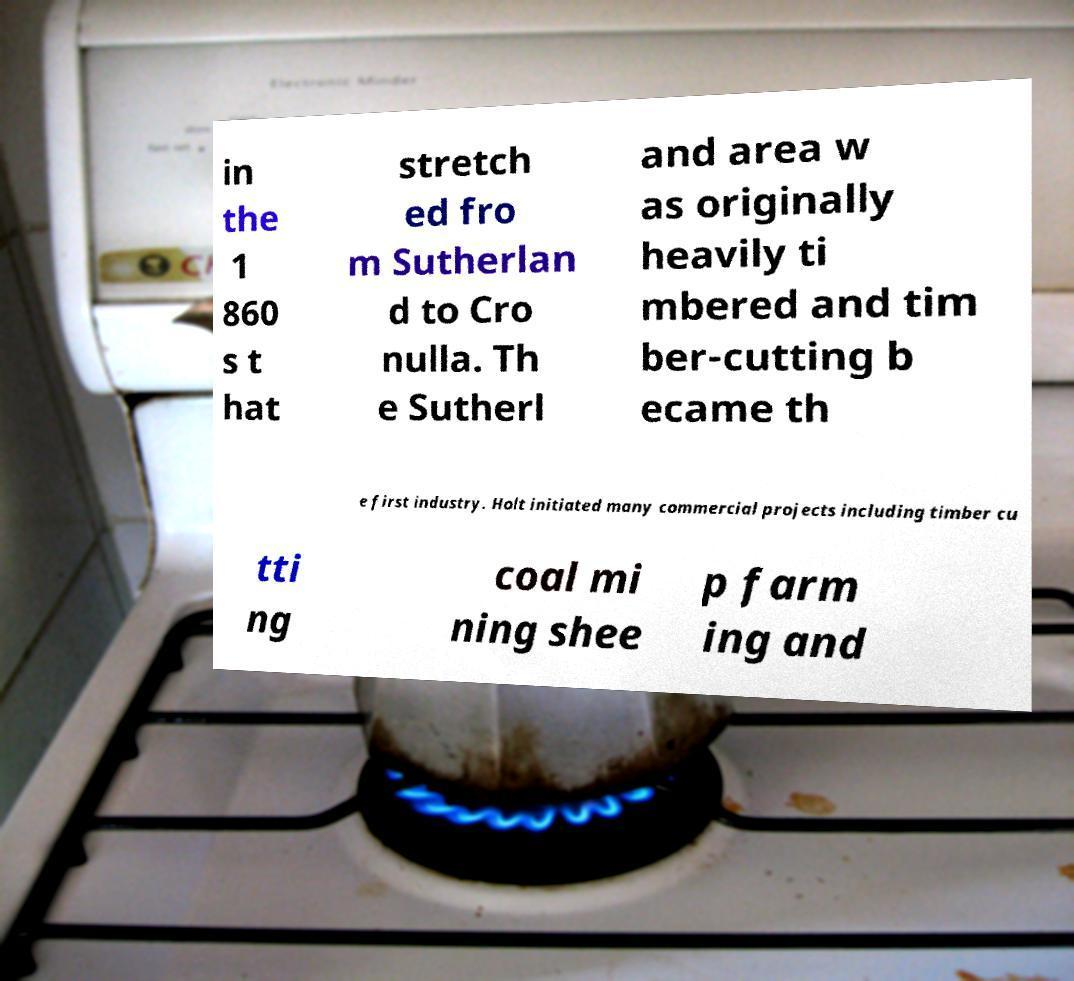Could you assist in decoding the text presented in this image and type it out clearly? in the 1 860 s t hat stretch ed fro m Sutherlan d to Cro nulla. Th e Sutherl and area w as originally heavily ti mbered and tim ber-cutting b ecame th e first industry. Holt initiated many commercial projects including timber cu tti ng coal mi ning shee p farm ing and 